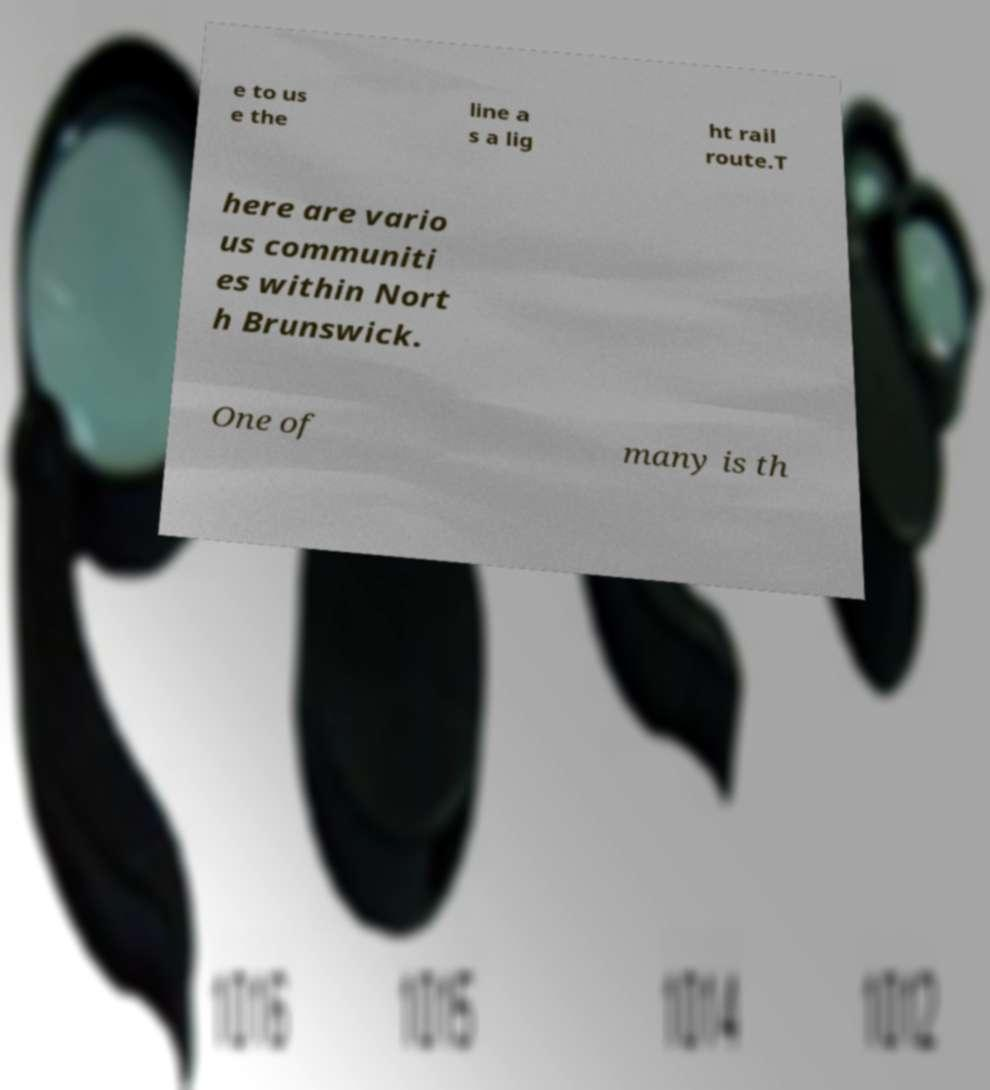Please identify and transcribe the text found in this image. e to us e the line a s a lig ht rail route.T here are vario us communiti es within Nort h Brunswick. One of many is th 